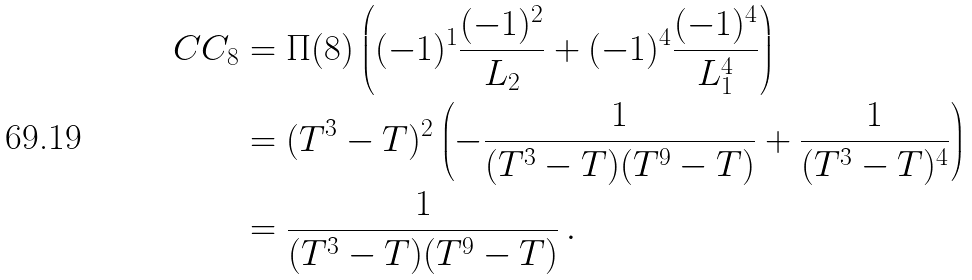Convert formula to latex. <formula><loc_0><loc_0><loc_500><loc_500>C C _ { 8 } & = \Pi ( 8 ) \left ( ( - 1 ) ^ { 1 } \frac { ( - 1 ) ^ { 2 } } { L _ { 2 } } + ( - 1 ) ^ { 4 } \frac { ( - 1 ) ^ { 4 } } { L _ { 1 } ^ { 4 } } \right ) \\ & = ( T ^ { 3 } - T ) ^ { 2 } \left ( - \frac { 1 } { ( T ^ { 3 } - T ) ( T ^ { 9 } - T ) } + \frac { 1 } { ( T ^ { 3 } - T ) ^ { 4 } } \right ) \\ & = \frac { 1 } { ( T ^ { 3 } - T ) ( T ^ { 9 } - T ) } \, .</formula> 